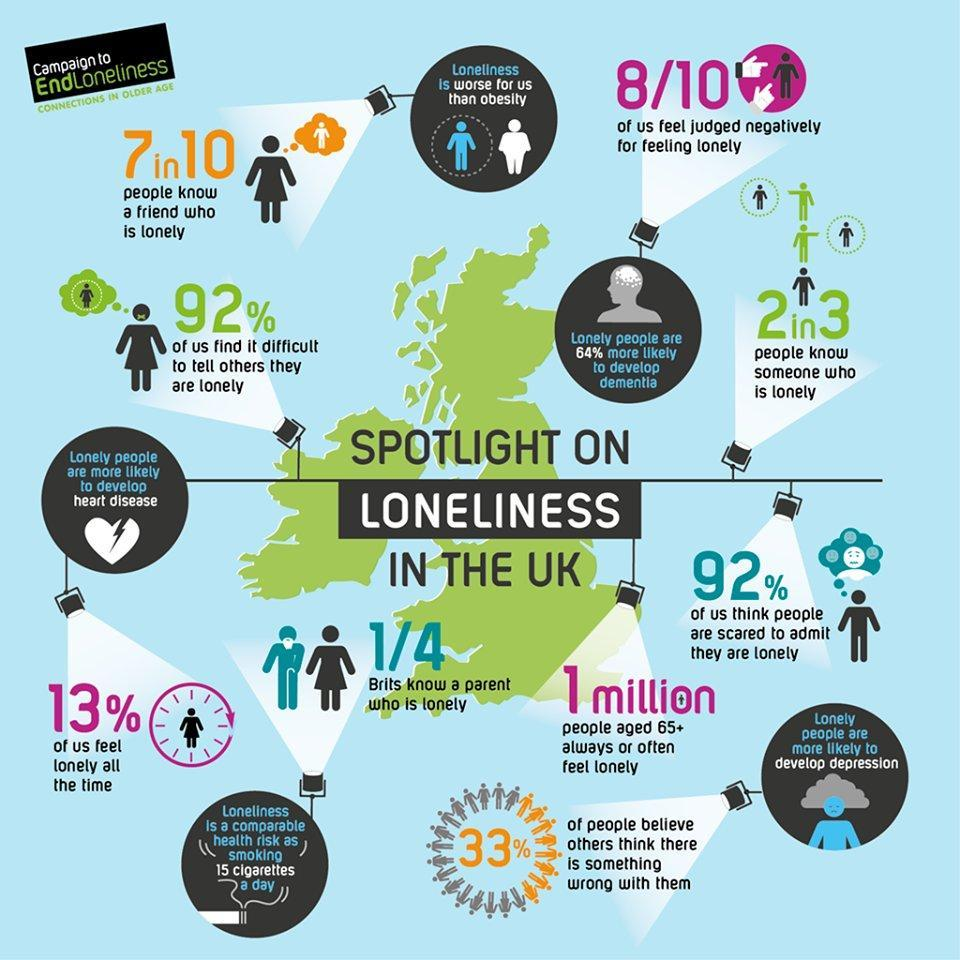What percentage of people are afraid of being judged negatively because of loneliness ?
Answer the question with a short phrase. 80% How many senior citizens often feel lonely ? 1 million What is obesity considered to be better off than ? Loneliness Name three health adversities that can be caused by loneliness ? Depression, dementia, heart diseases What percentage of people find  it easy to tell others that they are lonely ? 8% What percent of lonely people could develop dementia ? 64% 